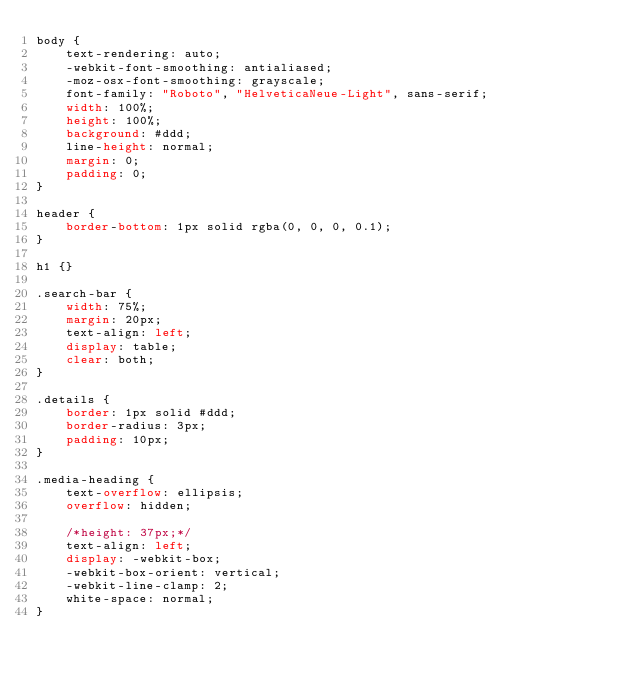Convert code to text. <code><loc_0><loc_0><loc_500><loc_500><_CSS_>body {
    text-rendering: auto;
    -webkit-font-smoothing: antialiased;
    -moz-osx-font-smoothing: grayscale;
    font-family: "Roboto", "HelveticaNeue-Light", sans-serif;
    width: 100%;
    height: 100%;
    background: #ddd;
    line-height: normal;
    margin: 0;
    padding: 0;
}

header {
    border-bottom: 1px solid rgba(0, 0, 0, 0.1);
}

h1 {}

.search-bar {
    width: 75%;
    margin: 20px;
    text-align: left;
    display: table;
    clear: both;
}

.details {
    border: 1px solid #ddd;
    border-radius: 3px;
    padding: 10px;
}

.media-heading {
    text-overflow: ellipsis;
    overflow: hidden;

    /*height: 37px;*/
    text-align: left;
    display: -webkit-box;
    -webkit-box-orient: vertical;
    -webkit-line-clamp: 2;
    white-space: normal;
}</code> 